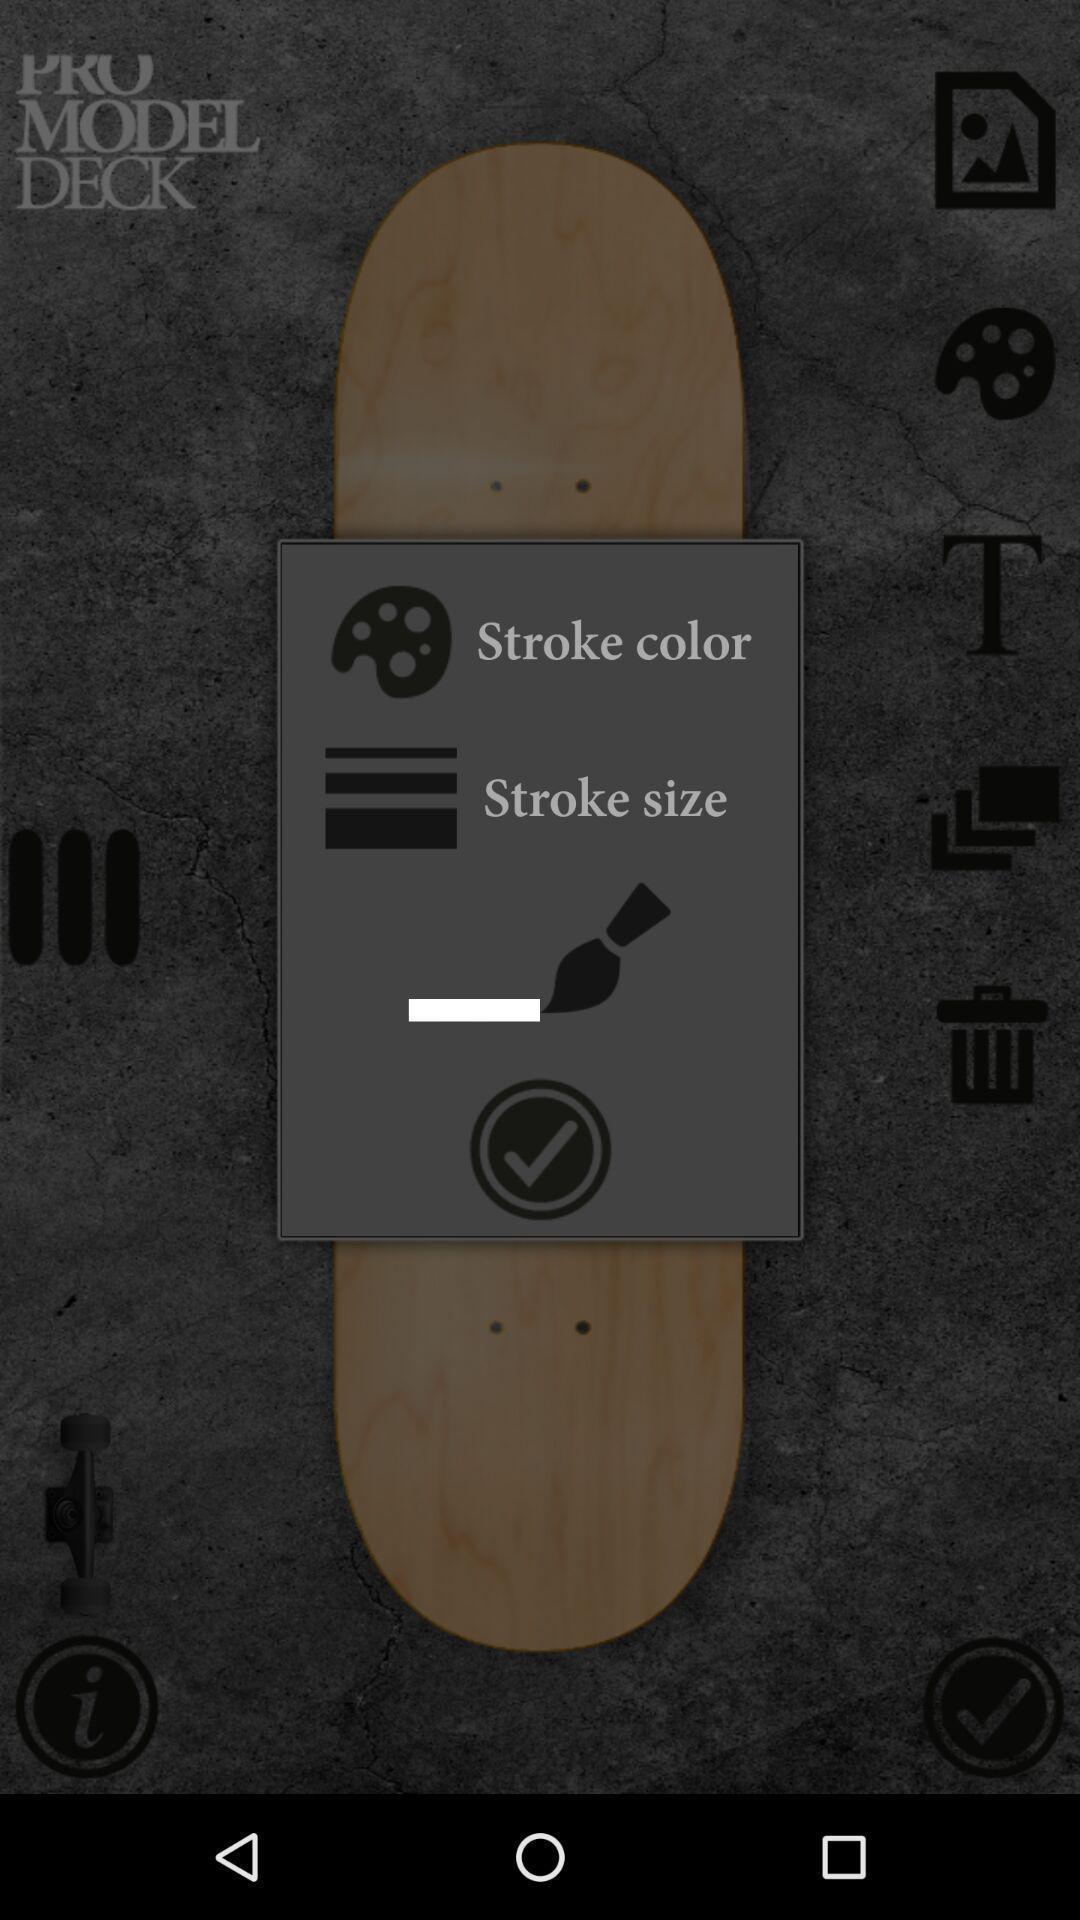Give me a summary of this screen capture. Skate board picture page in a skate designer app. 